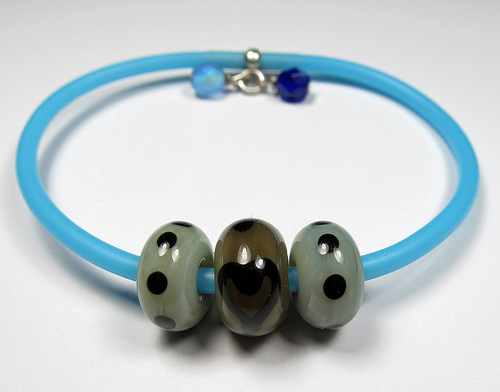<image>
Is the jewel in front of the chain? Yes. The jewel is positioned in front of the chain, appearing closer to the camera viewpoint. 